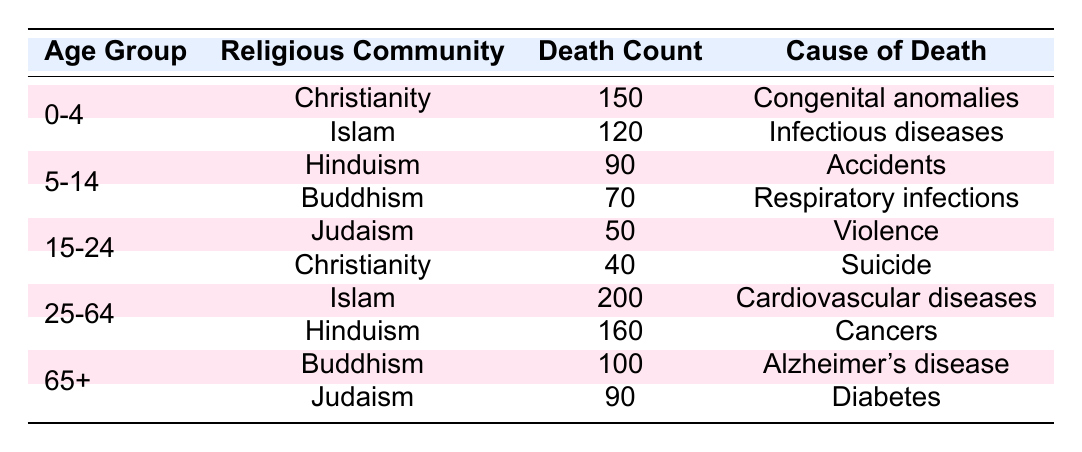What is the cause of death for the age group 0-4 in Christianity? In the table, under the age group 0-4 for the religious community of Christianity, the cause of death listed is "Congenital anomalies."
Answer: Congenital anomalies Which religious community has the highest death count for the age group 25-64? Looking at the age group 25-64, Islam has a death count of 200, which is higher than the 160 from Hinduism, making it the highest in this age group.
Answer: Islam What is the total number of deaths recorded for the age group 5-14? For the age group 5-14, the death counts are 90 (Hinduism) and 70 (Buddhism). Adding these values gives 90 + 70 = 160.
Answer: 160 Is it true that more women die from Alzheimer's disease than from diabetes in the age group 65+? In the 65+ age group, Buddhism has 100 deaths due to Alzheimer's disease, while Judaism has 90 deaths from diabetes. Since 100 is greater than 90, the statement is true.
Answer: Yes What is the average death count for the age group 15-24? For the age group 15-24, the death counts are 50 (Judaism) and 40 (Christianity). The total deaths are 50 + 40 = 90, and there are 2 entries, so the average is 90/2 = 45.
Answer: 45 Which cause of death is associated with the highest number of deaths for the age group 25-64? In the 25-64 age group, the causes of death are "Cardiovascular diseases" with 200 deaths (Islam) and "Cancers" with 160 deaths (Hinduism). Since 200 is greater than 160, the highest cause of death is "Cardiovascular diseases."
Answer: Cardiovascular diseases How many deaths are attributed to respiratory infections in total? The table shows respiratory infections resulting in 70 deaths for the age group 5-14 under Buddhism. This is the only entry for that cause of death in the provided data. Thus, the total is 70.
Answer: 70 If we add the deaths due to congenital anomalies and infectious diseases for the age group 0-4, what is the result? The death count for congenital anomalies (Christianity) is 150 and for infectious diseases (Islam) is 120. Summing these up gives 150 + 120 = 270.
Answer: 270 Which age group has the lowest recorded deaths from a singular cause of death across all religious communities? Looking at the age groups, the age 15-24 has 50 deaths due to violence (Judaism) and 40 deaths due to suicide (Christianity), which totals 90. The age group 0-4 has 150 + 120 = 270, 5-14 has 90 + 70 = 160, and 25-64 has 200 + 160 = 360, while the 65+ group has 100 + 90 = 190. Since 90 is the lowest recorded value for a singular cause, 15-24 is the answer.
Answer: 15-24 